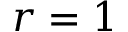Convert formula to latex. <formula><loc_0><loc_0><loc_500><loc_500>r = 1</formula> 